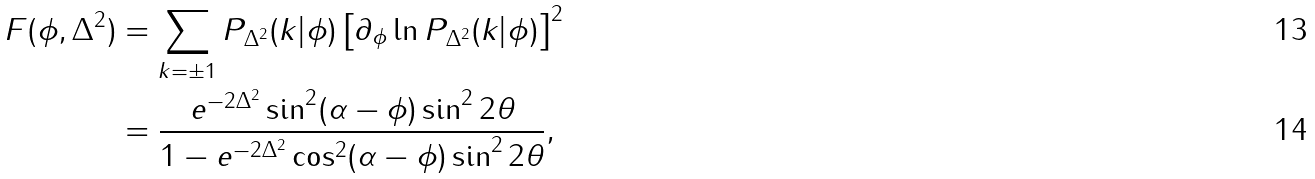Convert formula to latex. <formula><loc_0><loc_0><loc_500><loc_500>F ( \phi , \Delta ^ { 2 } ) & = \sum _ { k = \pm 1 } P _ { \Delta ^ { 2 } } ( k | \phi ) \left [ \partial _ { \phi } \ln P _ { \Delta ^ { 2 } } ( k | \phi ) \right ] ^ { 2 } \\ & = \frac { e ^ { - 2 \Delta ^ { 2 } } \sin ^ { 2 } ( \alpha - \phi ) \sin ^ { 2 } 2 \theta } { 1 - e ^ { - 2 \Delta ^ { 2 } } \cos ^ { 2 } ( \alpha - \phi ) \sin ^ { 2 } 2 \theta } ,</formula> 